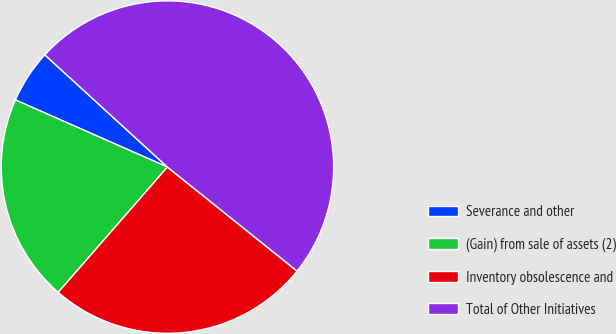Convert chart. <chart><loc_0><loc_0><loc_500><loc_500><pie_chart><fcel>Severance and other<fcel>(Gain) from sale of assets (2)<fcel>Inventory obsolescence and<fcel>Total of Other Initiatives<nl><fcel>5.18%<fcel>20.21%<fcel>25.65%<fcel>48.96%<nl></chart> 